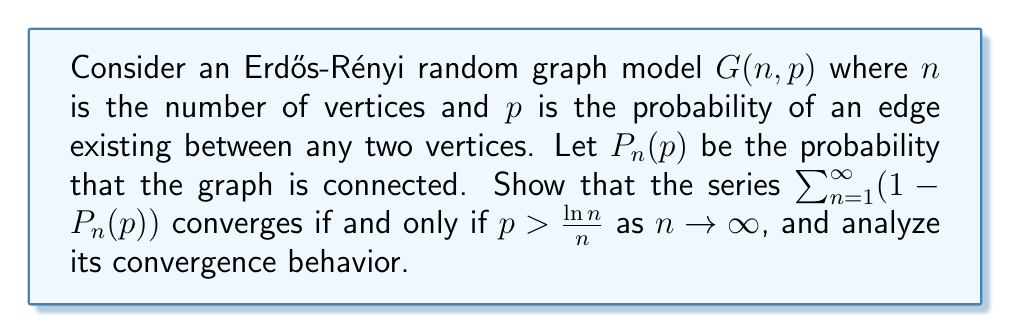Provide a solution to this math problem. To analyze the convergence of the series $\sum_{n=1}^{\infty} (1-P_n(p))$, we need to understand the behavior of $P_n(p)$ as $n$ approaches infinity.

1) First, recall a key result from random graph theory:
   For $p = \frac{c \ln n}{n}$ where $c > 1$, $P_n(p) \to 1$ as $n \to \infty$.
   For $p = \frac{c \ln n}{n}$ where $c < 1$, $P_n(p) \to 0$ as $n \to \infty$.

2) Now, let's consider the series term by term:
   $a_n = 1 - P_n(p)$

3) For the series to converge, we need $a_n \to 0$ as $n \to \infty$, which means $P_n(p) \to 1$.

4) Based on the result in step 1, this occurs when $p > \frac{\ln n}{n}$ as $n \to \infty$.

5) To prove convergence when $p > \frac{\ln n}{n}$:
   Let $p = \frac{c \ln n}{n}$ where $c > 1$.
   Then, $1 - P_n(p) \sim e^{-n^{c-1}}$ for large $n$.
   
   The series $\sum_{n=1}^{\infty} e^{-n^{c-1}}$ converges by the integral test:
   $$\int_{1}^{\infty} e^{-x^{c-1}} dx < \infty$$

6) To prove divergence when $p \leq \frac{\ln n}{n}$:
   In this case, $P_n(p) \not\to 1$, so $1 - P_n(p)$ doesn't approach 0.
   Therefore, the series diverges by the divergence test.

7) The convergence behavior depends on how quickly $p$ approaches 0 as $n$ increases:
   - If $p$ decreases slower than $\frac{\ln n}{n}$, the series converges.
   - If $p$ decreases at the same rate or faster than $\frac{\ln n}{n}$, the series diverges.

This result highlights the sharp threshold behavior in random graphs, where connectivity emerges rapidly as the edge probability crosses a critical value.
Answer: The series $\sum_{n=1}^{\infty} (1-P_n(p))$ converges if and only if $p > \frac{\ln n}{n}$ as $n \to \infty$. The convergence behavior is characterized by a sharp threshold: for $p = \frac{c \ln n}{n}$, the series converges when $c > 1$ and diverges when $c \leq 1$. 